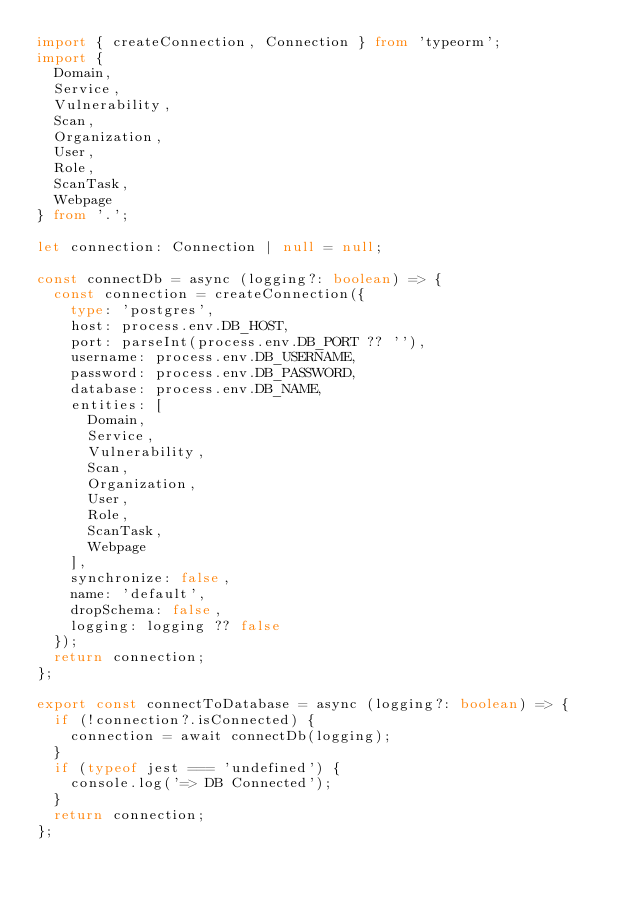<code> <loc_0><loc_0><loc_500><loc_500><_TypeScript_>import { createConnection, Connection } from 'typeorm';
import {
  Domain,
  Service,
  Vulnerability,
  Scan,
  Organization,
  User,
  Role,
  ScanTask,
  Webpage
} from '.';

let connection: Connection | null = null;

const connectDb = async (logging?: boolean) => {
  const connection = createConnection({
    type: 'postgres',
    host: process.env.DB_HOST,
    port: parseInt(process.env.DB_PORT ?? ''),
    username: process.env.DB_USERNAME,
    password: process.env.DB_PASSWORD,
    database: process.env.DB_NAME,
    entities: [
      Domain,
      Service,
      Vulnerability,
      Scan,
      Organization,
      User,
      Role,
      ScanTask,
      Webpage
    ],
    synchronize: false,
    name: 'default',
    dropSchema: false,
    logging: logging ?? false
  });
  return connection;
};

export const connectToDatabase = async (logging?: boolean) => {
  if (!connection?.isConnected) {
    connection = await connectDb(logging);
  }
  if (typeof jest === 'undefined') {
    console.log('=> DB Connected');
  }
  return connection;
};
</code> 